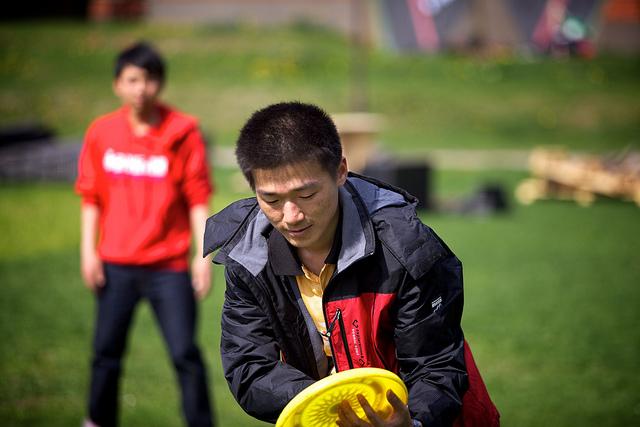What is the boy in red doing?
Give a very brief answer. Waiting. Is there fur on the coat?
Short answer required. No. How many women?
Quick response, please. 0. How many people have black hair?
Short answer required. 2. What is the guy in the front holding?
Short answer required. Frisbee. What color is the boy's hoody?
Concise answer only. Red. 